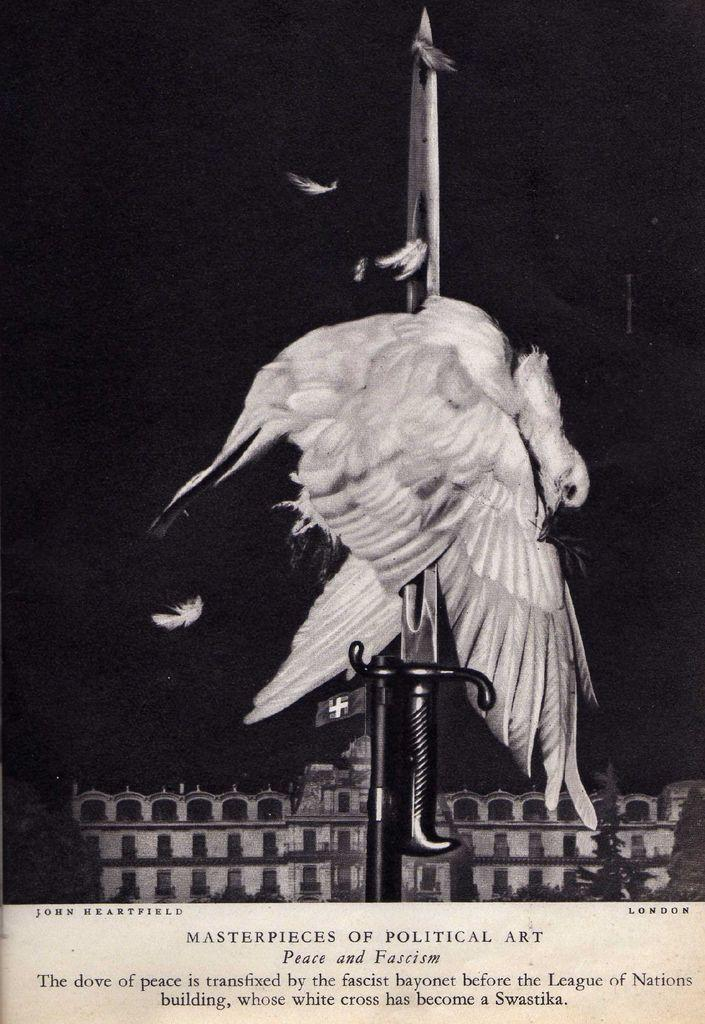<image>
Describe the image concisely. A poster of a Masterpiece of Political Art depicting a bird with a sword through its' body. 